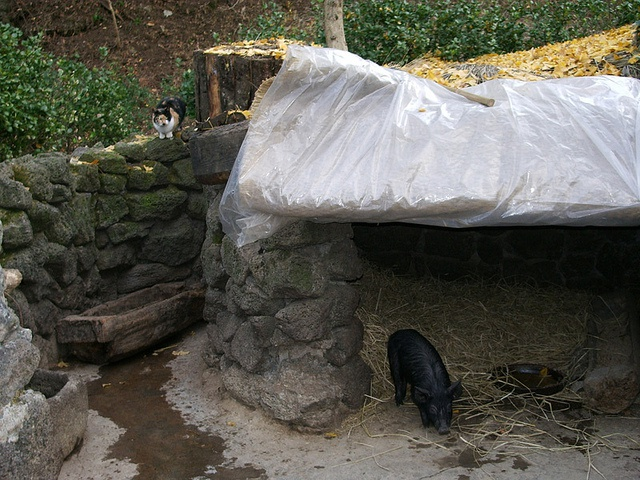Describe the objects in this image and their specific colors. I can see a cat in black, gray, darkgray, and darkgreen tones in this image. 